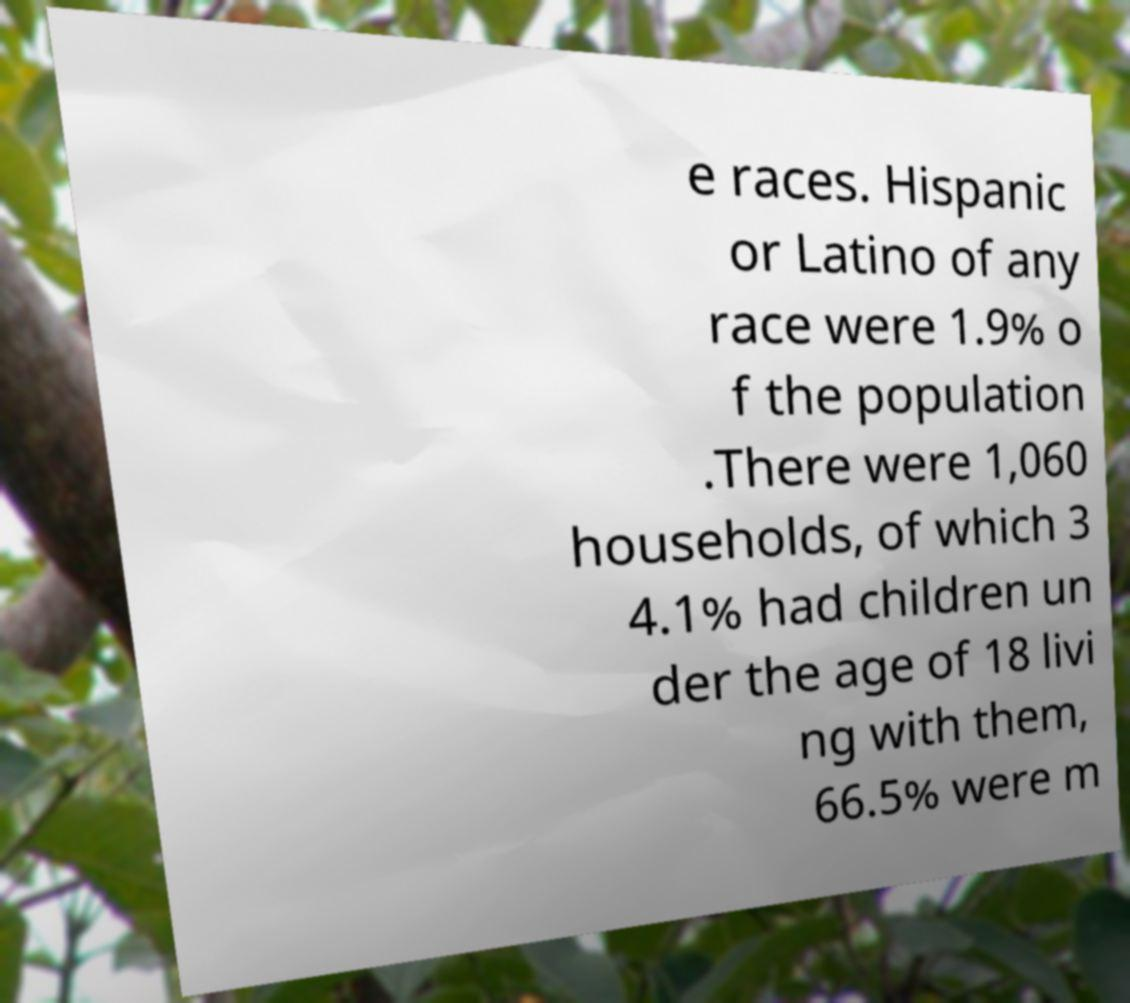There's text embedded in this image that I need extracted. Can you transcribe it verbatim? e races. Hispanic or Latino of any race were 1.9% o f the population .There were 1,060 households, of which 3 4.1% had children un der the age of 18 livi ng with them, 66.5% were m 